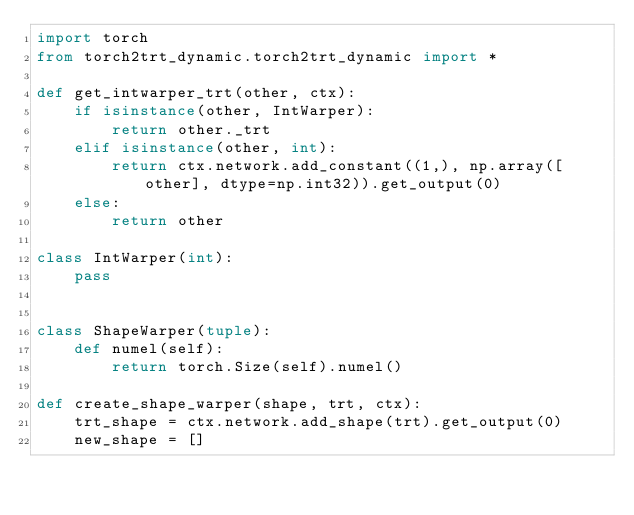Convert code to text. <code><loc_0><loc_0><loc_500><loc_500><_Python_>import torch
from torch2trt_dynamic.torch2trt_dynamic import *

def get_intwarper_trt(other, ctx):
    if isinstance(other, IntWarper):
        return other._trt
    elif isinstance(other, int):
        return ctx.network.add_constant((1,), np.array([other], dtype=np.int32)).get_output(0)
    else:
        return other

class IntWarper(int):
    pass
    

class ShapeWarper(tuple):
    def numel(self):
        return torch.Size(self).numel()

def create_shape_warper(shape, trt, ctx):
    trt_shape = ctx.network.add_shape(trt).get_output(0)
    new_shape = []</code> 